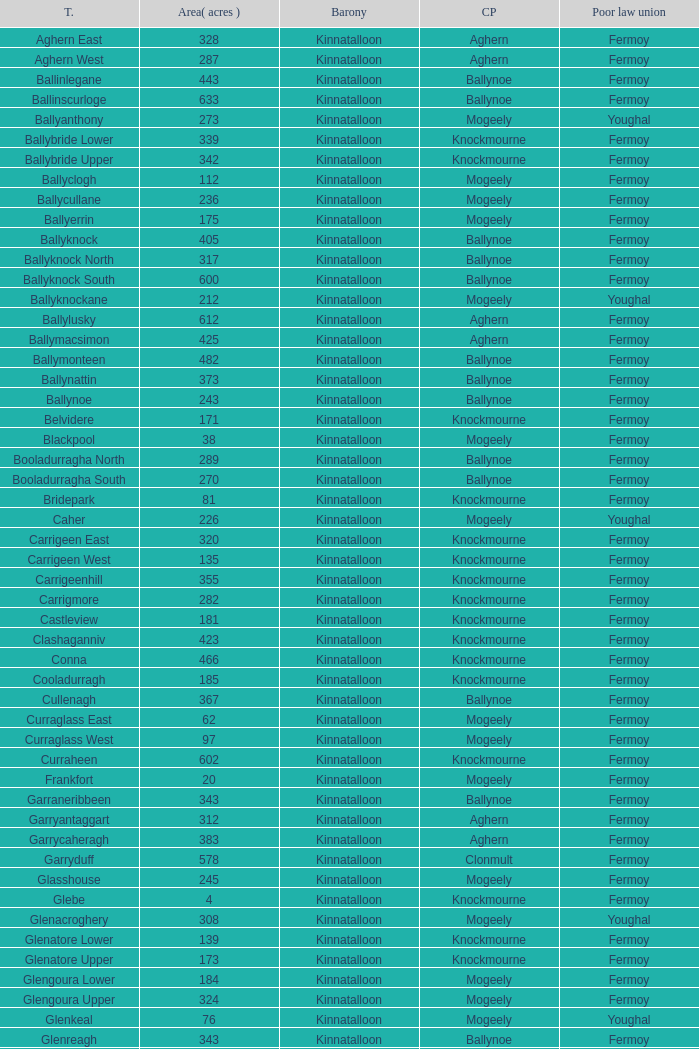Name the area for civil parish ballynoe and killasseragh 340.0. 